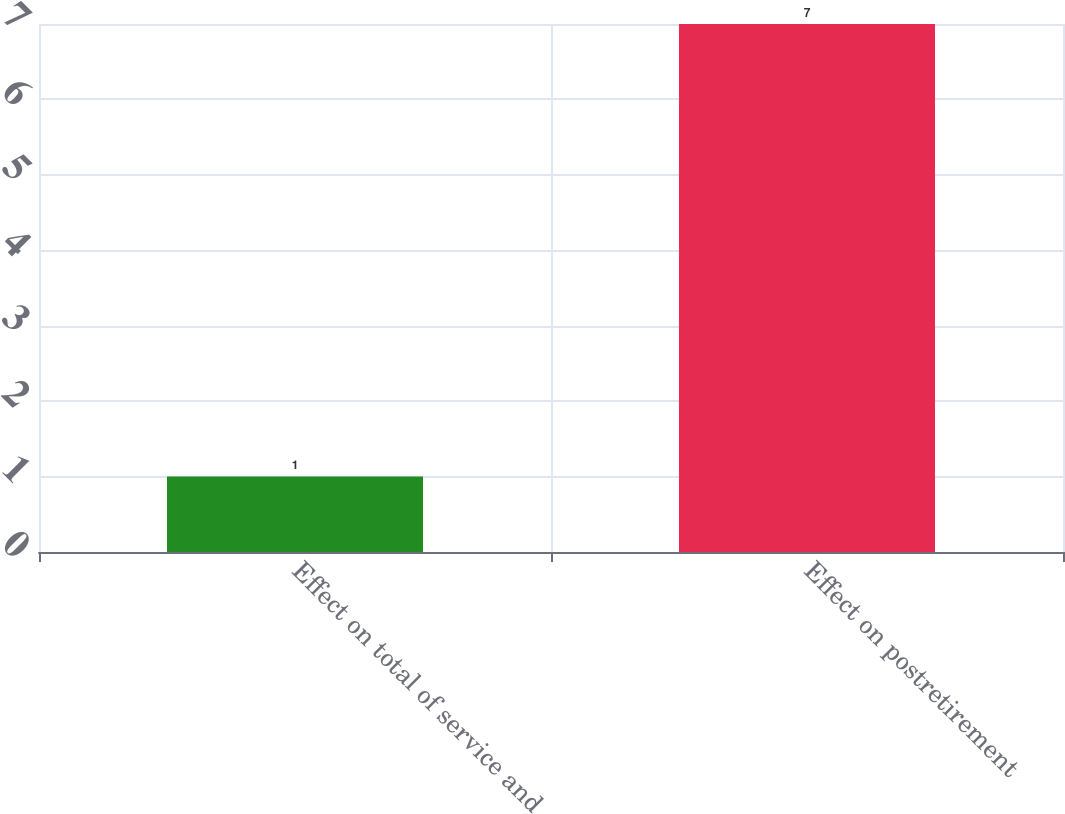<chart> <loc_0><loc_0><loc_500><loc_500><bar_chart><fcel>Effect on total of service and<fcel>Effect on postretirement<nl><fcel>1<fcel>7<nl></chart> 